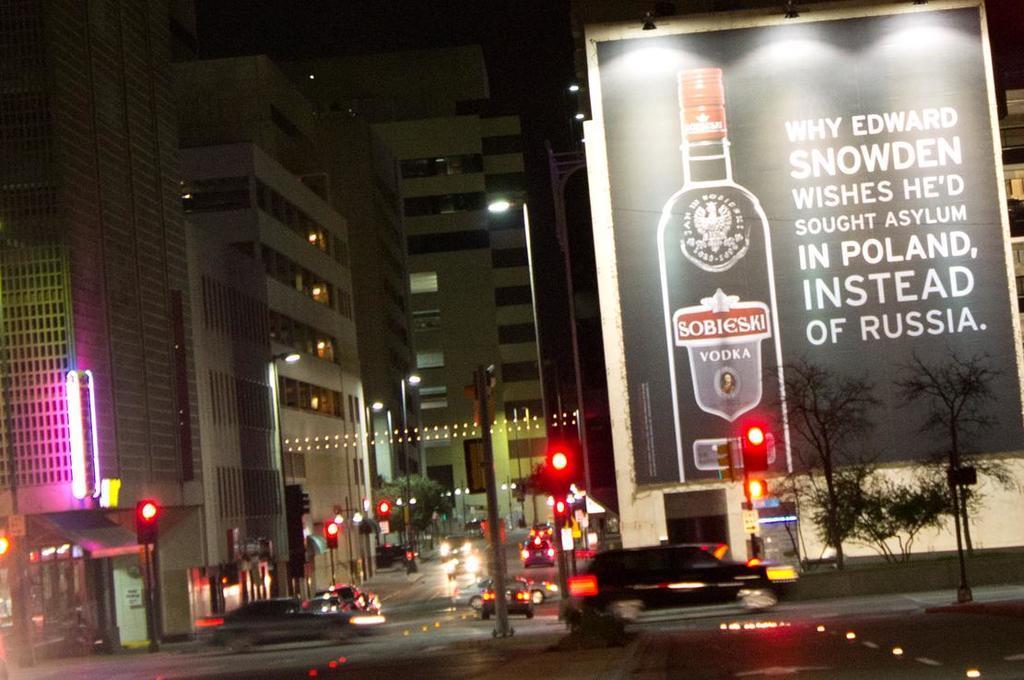How would you summarize this image in a sentence or two? In this image in the middle there are cars, lights, poles, buildings, car. On the right there are trees, lights, poster, text, car, building. 